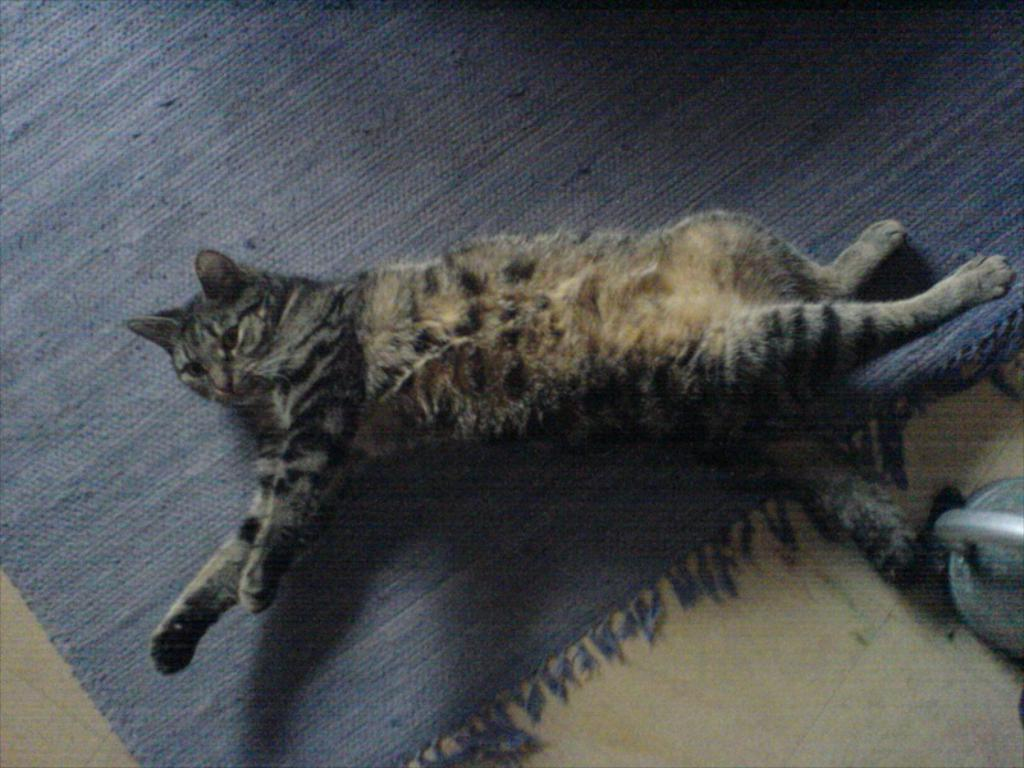What animal can be seen in the image? There is a cat lying on the carpet in the image. What color is the carpet that the cat is lying on? The carpet is blue in color. What part of the room is visible at the bottom of the image? The floor is visible at the bottom of the image. What object can be seen on the right side of the image? There is a kettle on the right side of the image. What title is given to the cat in the image? There is no title given to the cat in the image; it is simply a cat lying on the carpet. 